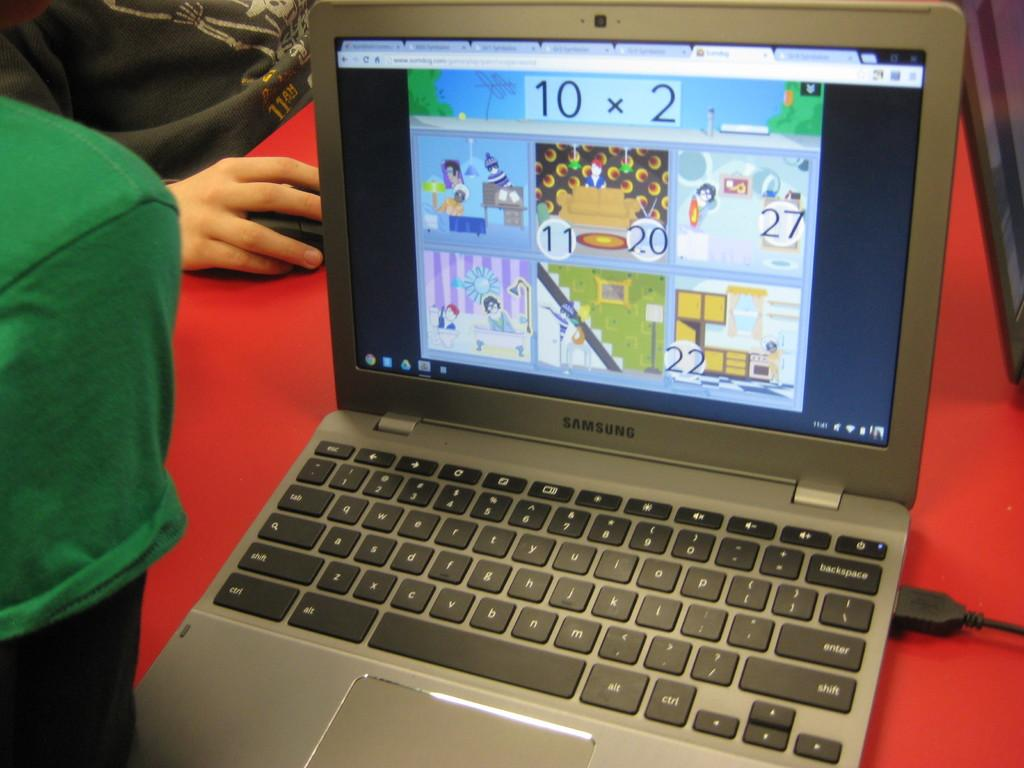<image>
Describe the image concisely. 10 x 2 is a math problem shown on the screen of this laptop. 